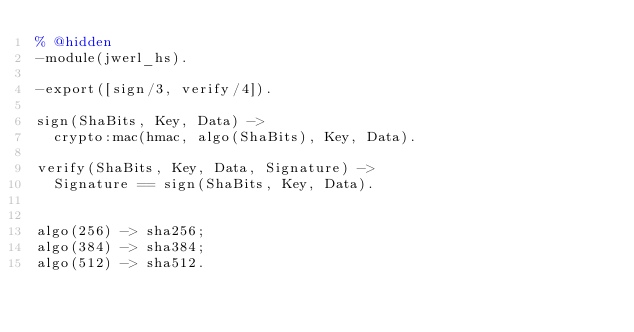Convert code to text. <code><loc_0><loc_0><loc_500><loc_500><_Erlang_>% @hidden
-module(jwerl_hs).

-export([sign/3, verify/4]).

sign(ShaBits, Key, Data) ->
  crypto:mac(hmac, algo(ShaBits), Key, Data).

verify(ShaBits, Key, Data, Signature) ->
  Signature == sign(ShaBits, Key, Data).


algo(256) -> sha256;
algo(384) -> sha384;
algo(512) -> sha512.
</code> 